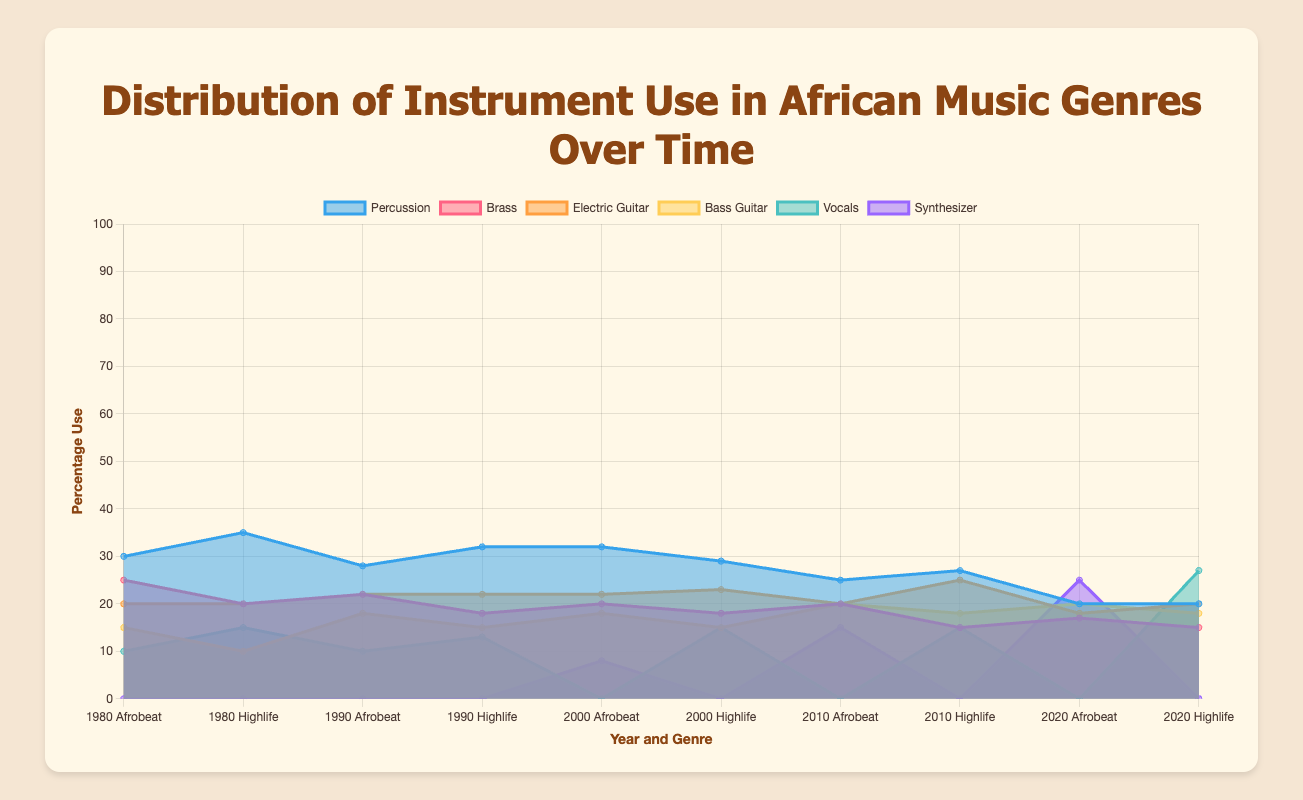What is the title of the chart? The title is displayed prominently at the top of the chart in a larger font. It helps viewers immediately understand the main subject of the visualization.
Answer: Distribution of Instrument Use in African Music Genres Over Time What are the years included in the data? The x-axis labels indicate the different years covered in the data. Each year is shown alongside the genre to which it is associated.
Answer: 1980, 1990, 2000, 2010, 2020 Which instrument had the highest percentage use in Highlife music in 2020? By looking at the specific segment for Highlife in 2020, the height of each colored band representing the instrument indicates the percentage use. The highest band represents Vocals.
Answer: Vocals How did the use of the Synthesizer in Afrobeat change from 2000 to 2020? By comparing the height of the Synthesizer segment in Afrobeat for the years 2000 and 2020, we can observe the change. The height is much greater in 2020 than in 2000.
Answer: Increased Which genre showed more variation in instrument use over the years, Afrobeat or Highlife? To determine the variation, compare the changes in the height of each instrument's segments for both genres over multiple years. Afrobeat shows more variation, especially with the introduction and increase in Synthesizer use.
Answer: Afrobeat What percentage of Brass was used in Afrobeat in 1990 and how does it compare to its usage in 2010? Check the Brass segment's height for Afrobeat in 1990 and 2010 and compare the values. In 1990, Brass had a higher percentage than in 2010.
Answer: It decreased Between 1980 and 2020, which instrument saw the most significant increase in use in Highlife? Examine the changes in the height of the segments representing each instrument for Highlife from 1980 to 2020. Vocals showed the most significant increase.
Answer: Vocals In what year did the Electric Guitar in Highlife reach its peak percentage use? Review the Electric Guitar segment for Highlife across all years. The peak is in 2010.
Answer: 2010 How did the use of Percussion instruments in Afrobeat change from 1980 to 2020? Compare the height of the Percussion segment in Afrobeat for the years 1980 and 2020. The Percussion segment was higher in 1980, indicating it decreased over time.
Answer: Decreased What instruments were consistently used across all years in both genres? By observing each year's data, identify the instruments that appear in every year for both Afrobeat and Highlife. Percussion, Electric Guitar, Bass Guitar, and Brass are used consistently.
Answer: Percussion, Electric Guitar, Bass Guitar, Brass 